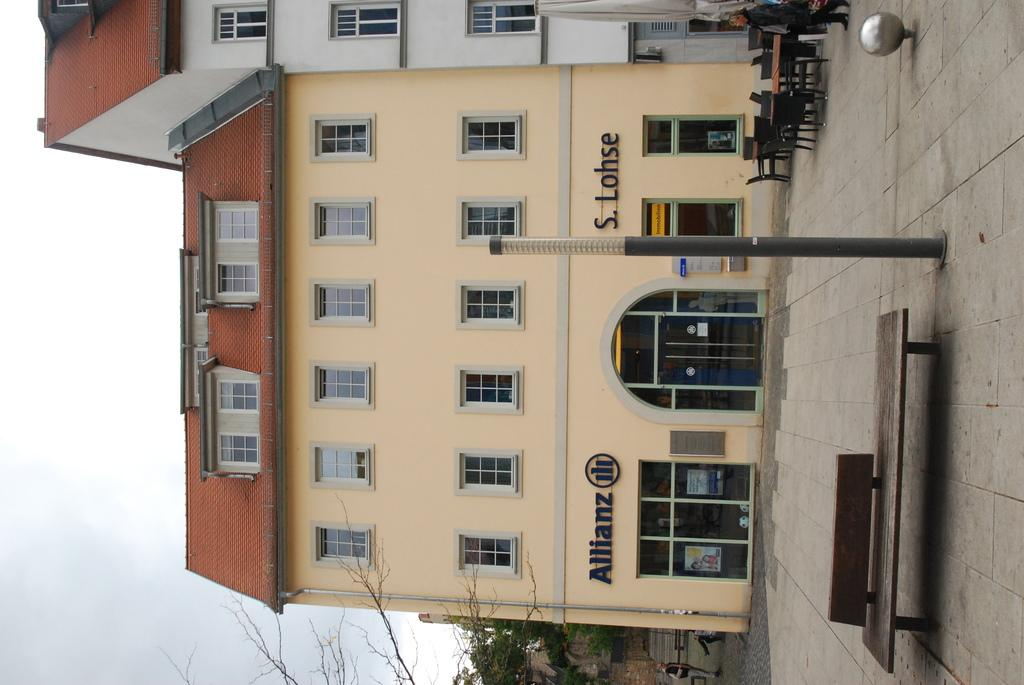Provide a one-sentence caption for the provided image. The Allianz company is located in this building. 